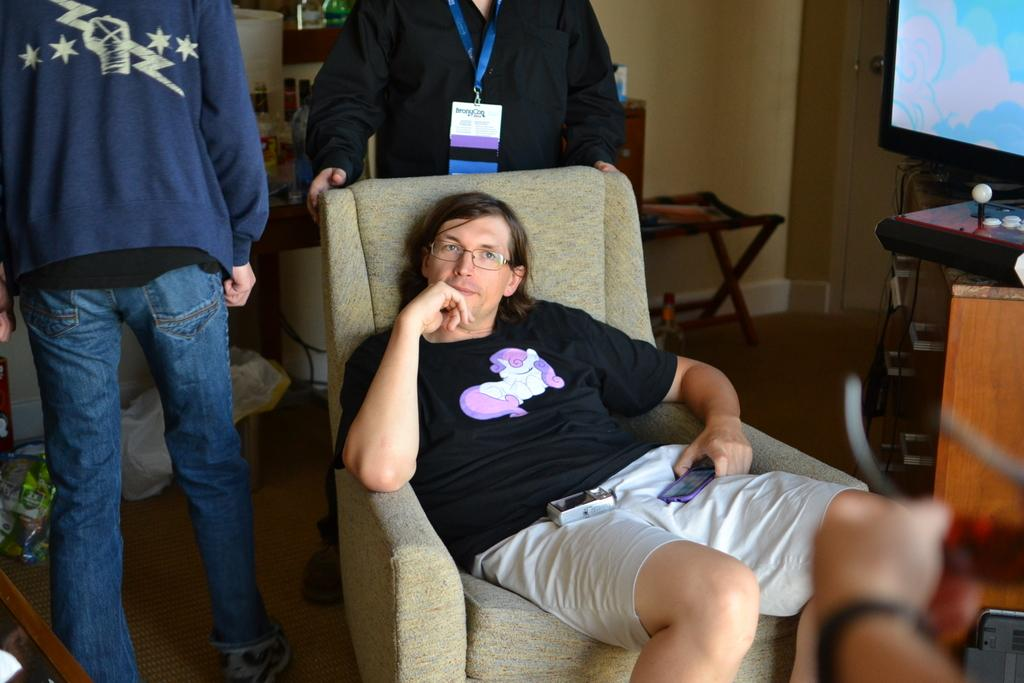What is the man in the image doing? The man is sitting on a couch in the image. Can you describe the people in the background of the image? There are two other people standing in the background of the image. What can be seen on the wall in the background of the image? There is a television screen and a joystick visible on the wall in the background of the image. What is the setting of the image? The image appears to be set in a room with a couch and a wall. What type of quill is the man using in the image? There is no quill present in the image. 